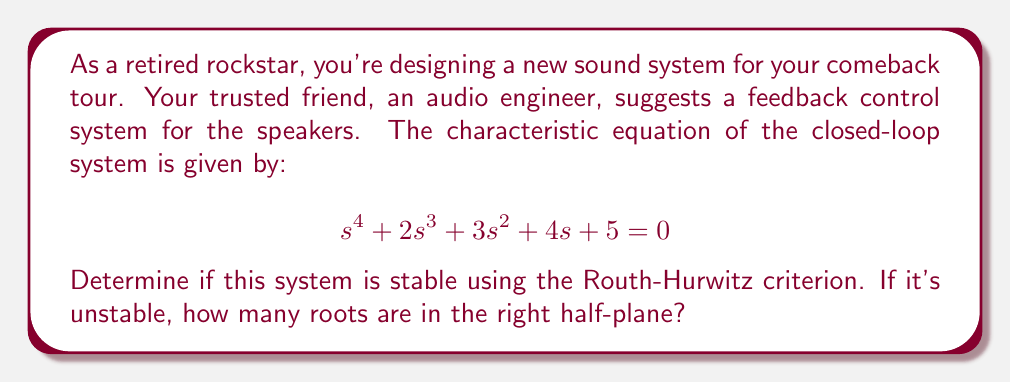Help me with this question. Let's apply the Routh-Hurwitz criterion to determine the stability of the system:

1) First, we create the Routh array:

   $$\begin{array}{c|c c c}
   s^4 & 1 & 3 & 5 \\
   s^3 & 2 & 4 & 0 \\
   s^2 & b_1 & b_2 & \\
   s^1 & c_1 & & \\
   s^0 & d_1 & &
   \end{array}$$

2) Calculate $b_1$:
   $$b_1 = \frac{(2)(3) - (1)(4)}{2} = \frac{6-4}{2} = 1$$

3) Calculate $b_2$:
   $$b_2 = \frac{(2)(5) - (1)(0)}{2} = 5$$

4) Calculate $c_1$:
   $$c_1 = \frac{(1)(4) - (2)(5)}{1} = 4 - 10 = -6$$

5) Calculate $d_1$:
   $$d_1 = 5$$ (as $b_2 = 5$)

6) The complete Routh array:

   $$\begin{array}{c|c c c}
   s^4 & 1 & 3 & 5 \\
   s^3 & 2 & 4 & 0 \\
   s^2 & 1 & 5 & \\
   s^1 & -6 & & \\
   s^0 & 5 & &
   \end{array}$$

7) According to the Routh-Hurwitz criterion, the number of sign changes in the first column of the Routh array equals the number of roots in the right half-plane.

8) In this case, we have two sign changes in the first column (from 1 to -6, and from -6 to 5).

Therefore, the system is unstable, with two roots in the right half-plane.
Answer: The system is unstable with 2 roots in the right half-plane. 